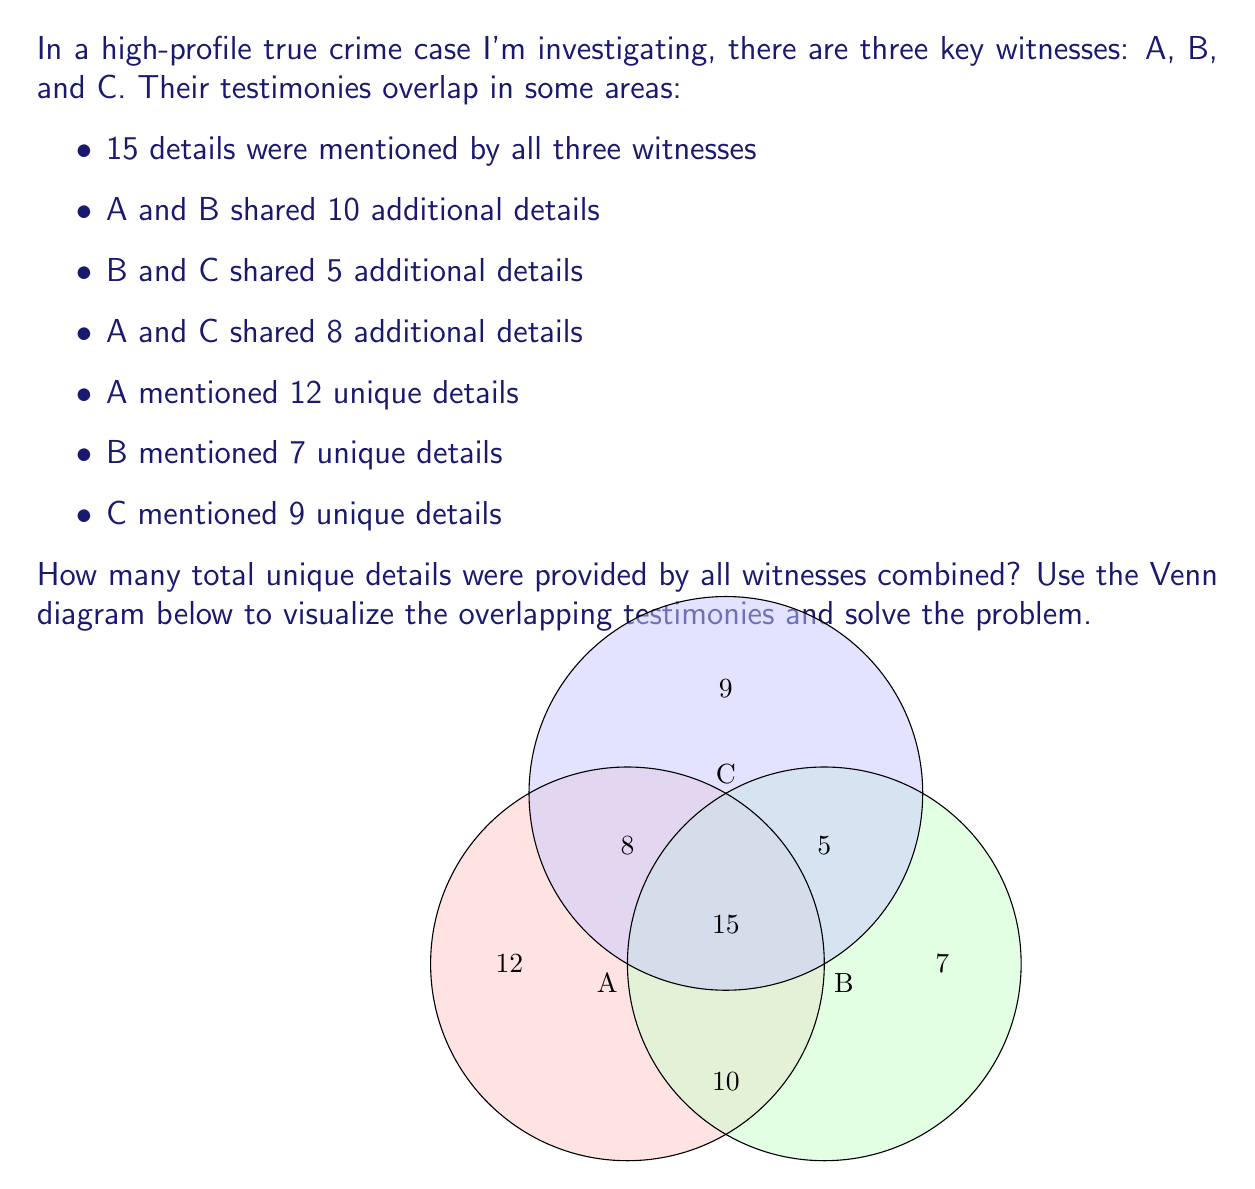Teach me how to tackle this problem. To solve this problem, we'll use the concept of sets and the principle of inclusion-exclusion. Let's break it down step-by-step:

1) First, let's identify the given information:
   - $|A \cap B \cap C| = 15$ (details shared by all three)
   - $|A \cap B| - |A \cap B \cap C| = 10$ (additional details shared by A and B)
   - $|B \cap C| - |A \cap B \cap C| = 5$ (additional details shared by B and C)
   - $|A \cap C| - |A \cap B \cap C| = 8$ (additional details shared by A and C)
   - $|A| - |A \cap (B \cup C)| = 12$ (unique details from A)
   - $|B| - |B \cap (A \cup C)| = 7$ (unique details from B)
   - $|C| - |C \cap (A \cup B)| = 9$ (unique details from C)

2) Now, let's calculate the total number of unique details. We can use the principle of inclusion-exclusion:

   $|A \cup B \cup C| = |A| + |B| + |C| - |A \cap B| - |B \cap C| - |A \cap C| + |A \cap B \cap C|$

3) We need to calculate $|A|$, $|B|$, and $|C|$ first:
   $|A| = 12 + (10 + 8) + 15 = 45$
   $|B| = 7 + (10 + 5) + 15 = 37$
   $|C| = 9 + (5 + 8) + 15 = 37$

4) Now we can substitute these values into our equation:

   $|A \cup B \cup C| = 45 + 37 + 37 - (25 + 20 + 23) + 15$

5) Simplifying:
   $|A \cup B \cup C| = 119 - 68 + 15 = 66$

Therefore, the total number of unique details provided by all witnesses combined is 66.
Answer: 66 unique details 